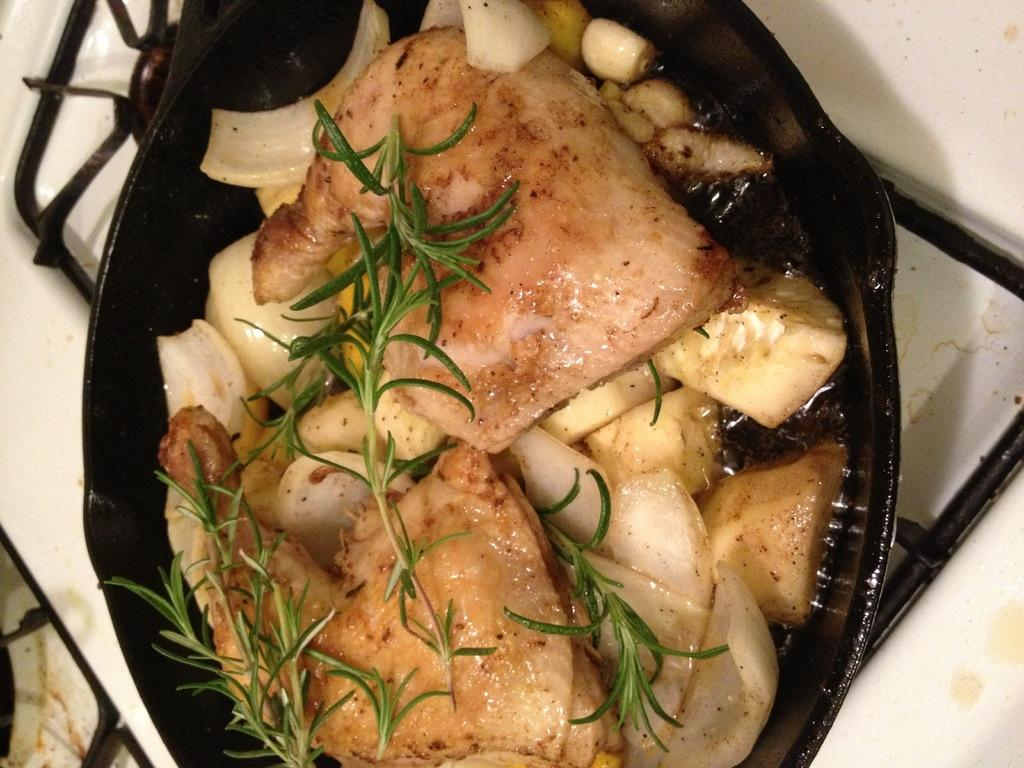What is in the bowl that is visible in the image? There is food in a bowl in the image. Where is the bowl located in the image? The bowl is on a stove. How many dolls are sitting on the turkey in the image? There are no dolls or turkey present in the image. 